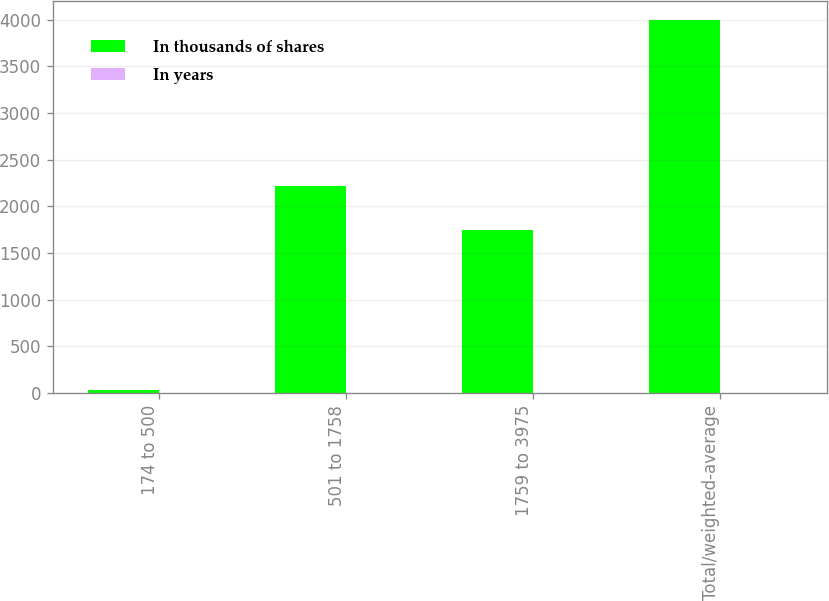Convert chart. <chart><loc_0><loc_0><loc_500><loc_500><stacked_bar_chart><ecel><fcel>174 to 500<fcel>501 to 1758<fcel>1759 to 3975<fcel>Total/weighted-average<nl><fcel>In thousands of shares<fcel>35<fcel>2214<fcel>1750<fcel>3999<nl><fcel>In years<fcel>3.8<fcel>2.4<fcel>1.2<fcel>1.9<nl></chart> 